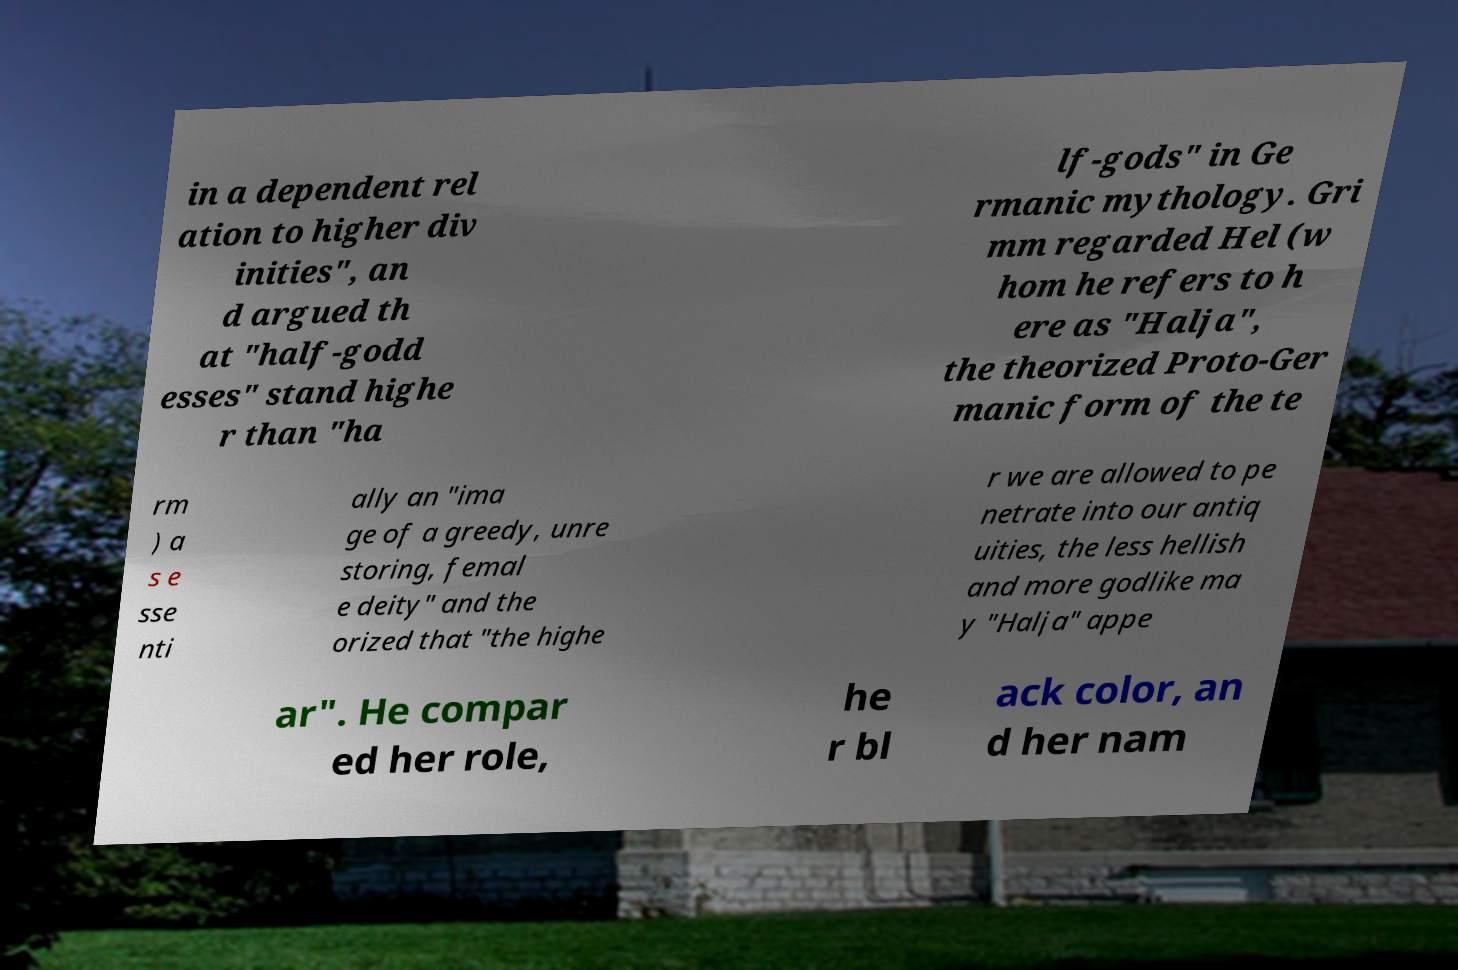Could you assist in decoding the text presented in this image and type it out clearly? in a dependent rel ation to higher div inities", an d argued th at "half-godd esses" stand highe r than "ha lf-gods" in Ge rmanic mythology. Gri mm regarded Hel (w hom he refers to h ere as "Halja", the theorized Proto-Ger manic form of the te rm ) a s e sse nti ally an "ima ge of a greedy, unre storing, femal e deity" and the orized that "the highe r we are allowed to pe netrate into our antiq uities, the less hellish and more godlike ma y "Halja" appe ar". He compar ed her role, he r bl ack color, an d her nam 